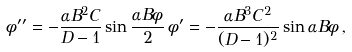<formula> <loc_0><loc_0><loc_500><loc_500>\phi ^ { \prime \prime } = - \frac { \alpha B ^ { 2 } C } { D - 1 } \sin \frac { \alpha B \phi } { 2 } \, \phi ^ { \prime } = - \frac { \alpha B ^ { 3 } C ^ { 2 } } { ( D - 1 ) ^ { 2 } } \sin \alpha B \phi \, ,</formula> 